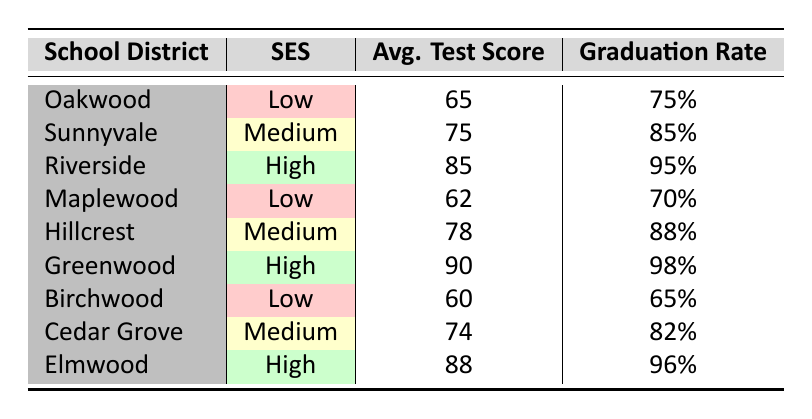What is the average test score in the Riverside School District? The average test score listed for the Riverside School District is 85.
Answer: 85 How many school districts have a low socioeconomic status? By examining the table, the school districts with low socioeconomic status are Oakwood, Maplewood, and Birchwood, totaling three districts.
Answer: 3 Which school district has the highest graduation rate? The highest graduation rate in the table is for Greenwood School District, which has a rate of 98%.
Answer: 98% What is the difference between the average test scores of high and low socioeconomic status districts? The average test score for high socioeconomic status districts (Riverside: 85, Greenwood: 90, Elmwood: 88) is (85 + 90 + 88) / 3 = 87.67. For low socioeconomic status districts (Oakwood: 65, Maplewood: 62, Birchwood: 60), it is (65 + 62 + 60) / 3 = 62.33. The difference between 87.67 and 62.33 is 25.34.
Answer: 25.34 Is the graduation rate in the Sunnyvale School District higher than the average graduation rate of all districts combined? To find the average graduation rate, we sum all the graduation rates: (75 + 85 + 95 + 70 + 88 + 98 + 65 + 82 + 96) / 9 = 82.22. Sunnyvale's graduation rate is 85, which is higher than 82.22.
Answer: Yes Which socioeconomic status category has the lowest average test scores? The average test scores are 65 for low (Oakwood), 76.33 for medium (Sunnyvale: 75, Hillcrest: 78, Cedar Grove: 74), and 87.67 for high (Riverside: 85, Greenwood: 90, Elmwood: 88). The lowest average test scores belong to the low socioeconomic status category.
Answer: Low What are the graduation rates of medium socioeconomic status districts? The medium socioeconomic status districts listed are Sunnyvale (85%), Hillcrest (88%), and Cedar Grove (82%). Their graduation rates are: 85, 88, and 82.
Answer: 85%, 88%, 82% 